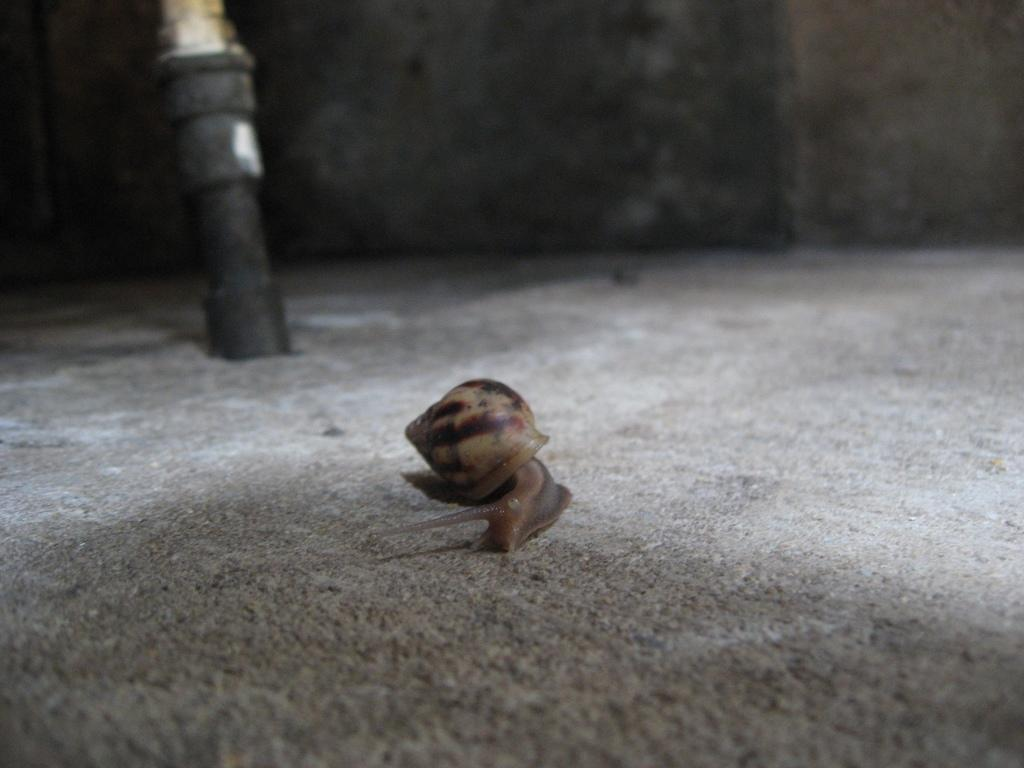What is the main subject of the image? There is a snail in the image. Where is the snail located? The snail is on a surface. What can be seen in the background of the image? There is a black object and a wall in the background of the image. What rate is the snail moving at in the image? The snail's movement cannot be determined from the image, as it is a still photograph. Is there a notebook visible in the image? There is no notebook present in the image. 